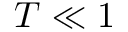<formula> <loc_0><loc_0><loc_500><loc_500>T \ll 1</formula> 